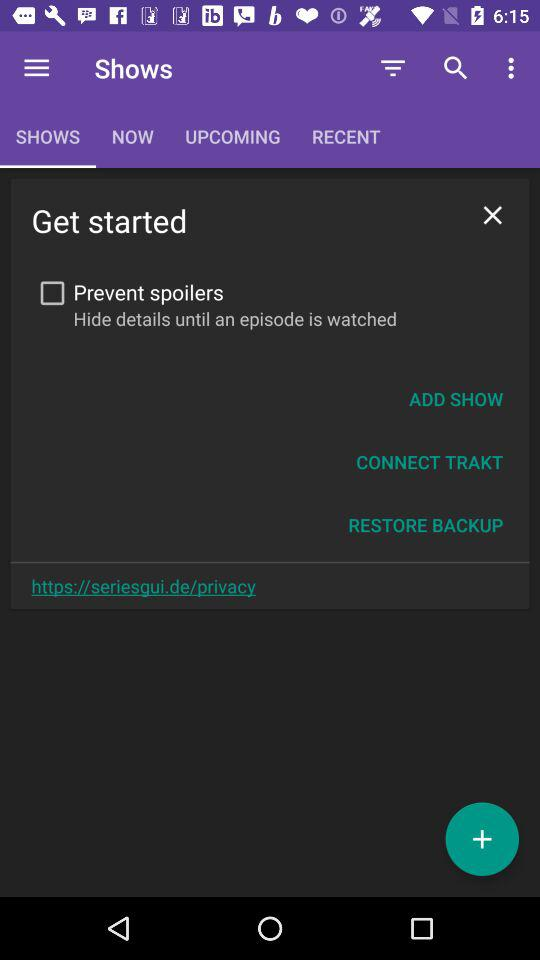Which option is selected? The selected option is "SHOWS". 